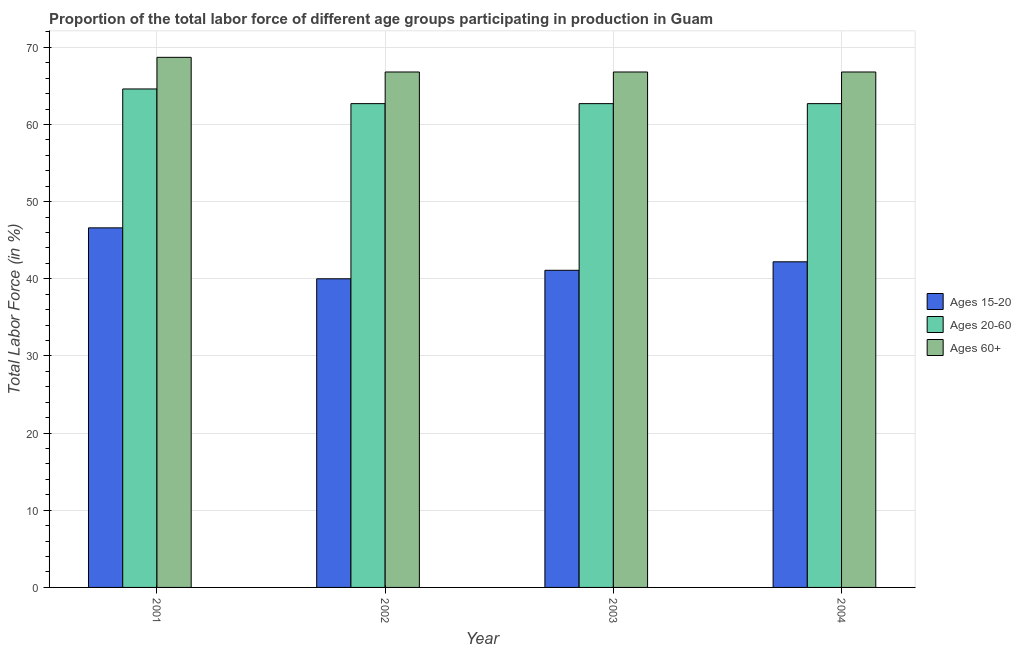How many groups of bars are there?
Your answer should be very brief. 4. Are the number of bars per tick equal to the number of legend labels?
Keep it short and to the point. Yes. Are the number of bars on each tick of the X-axis equal?
Give a very brief answer. Yes. How many bars are there on the 3rd tick from the left?
Your response must be concise. 3. What is the label of the 4th group of bars from the left?
Ensure brevity in your answer.  2004. What is the percentage of labor force above age 60 in 2003?
Offer a terse response. 66.8. Across all years, what is the maximum percentage of labor force within the age group 15-20?
Your answer should be very brief. 46.6. Across all years, what is the minimum percentage of labor force within the age group 15-20?
Offer a very short reply. 40. In which year was the percentage of labor force within the age group 20-60 minimum?
Offer a very short reply. 2002. What is the total percentage of labor force within the age group 15-20 in the graph?
Provide a succinct answer. 169.9. What is the difference between the percentage of labor force within the age group 15-20 in 2001 and that in 2004?
Provide a succinct answer. 4.4. What is the difference between the percentage of labor force above age 60 in 2003 and the percentage of labor force within the age group 20-60 in 2001?
Offer a terse response. -1.9. What is the average percentage of labor force within the age group 20-60 per year?
Ensure brevity in your answer.  63.18. In the year 2002, what is the difference between the percentage of labor force within the age group 15-20 and percentage of labor force above age 60?
Provide a short and direct response. 0. What is the ratio of the percentage of labor force within the age group 15-20 in 2002 to that in 2003?
Your response must be concise. 0.97. Is the percentage of labor force above age 60 in 2001 less than that in 2004?
Your response must be concise. No. What is the difference between the highest and the second highest percentage of labor force within the age group 15-20?
Give a very brief answer. 4.4. What is the difference between the highest and the lowest percentage of labor force within the age group 15-20?
Ensure brevity in your answer.  6.6. What does the 2nd bar from the left in 2003 represents?
Offer a very short reply. Ages 20-60. What does the 1st bar from the right in 2002 represents?
Provide a short and direct response. Ages 60+. Is it the case that in every year, the sum of the percentage of labor force within the age group 15-20 and percentage of labor force within the age group 20-60 is greater than the percentage of labor force above age 60?
Provide a short and direct response. Yes. How many bars are there?
Provide a succinct answer. 12. Are all the bars in the graph horizontal?
Make the answer very short. No. What is the difference between two consecutive major ticks on the Y-axis?
Ensure brevity in your answer.  10. Are the values on the major ticks of Y-axis written in scientific E-notation?
Provide a short and direct response. No. Where does the legend appear in the graph?
Keep it short and to the point. Center right. How are the legend labels stacked?
Offer a very short reply. Vertical. What is the title of the graph?
Your response must be concise. Proportion of the total labor force of different age groups participating in production in Guam. Does "Labor Market" appear as one of the legend labels in the graph?
Your answer should be very brief. No. What is the Total Labor Force (in %) in Ages 15-20 in 2001?
Ensure brevity in your answer.  46.6. What is the Total Labor Force (in %) in Ages 20-60 in 2001?
Your answer should be very brief. 64.6. What is the Total Labor Force (in %) in Ages 60+ in 2001?
Give a very brief answer. 68.7. What is the Total Labor Force (in %) in Ages 20-60 in 2002?
Your answer should be compact. 62.7. What is the Total Labor Force (in %) of Ages 60+ in 2002?
Give a very brief answer. 66.8. What is the Total Labor Force (in %) of Ages 15-20 in 2003?
Offer a terse response. 41.1. What is the Total Labor Force (in %) in Ages 20-60 in 2003?
Keep it short and to the point. 62.7. What is the Total Labor Force (in %) in Ages 60+ in 2003?
Give a very brief answer. 66.8. What is the Total Labor Force (in %) in Ages 15-20 in 2004?
Your answer should be compact. 42.2. What is the Total Labor Force (in %) of Ages 20-60 in 2004?
Your answer should be very brief. 62.7. What is the Total Labor Force (in %) in Ages 60+ in 2004?
Make the answer very short. 66.8. Across all years, what is the maximum Total Labor Force (in %) in Ages 15-20?
Provide a succinct answer. 46.6. Across all years, what is the maximum Total Labor Force (in %) of Ages 20-60?
Offer a very short reply. 64.6. Across all years, what is the maximum Total Labor Force (in %) in Ages 60+?
Provide a succinct answer. 68.7. Across all years, what is the minimum Total Labor Force (in %) in Ages 15-20?
Your answer should be very brief. 40. Across all years, what is the minimum Total Labor Force (in %) in Ages 20-60?
Your answer should be compact. 62.7. Across all years, what is the minimum Total Labor Force (in %) of Ages 60+?
Provide a succinct answer. 66.8. What is the total Total Labor Force (in %) of Ages 15-20 in the graph?
Ensure brevity in your answer.  169.9. What is the total Total Labor Force (in %) of Ages 20-60 in the graph?
Provide a short and direct response. 252.7. What is the total Total Labor Force (in %) in Ages 60+ in the graph?
Your response must be concise. 269.1. What is the difference between the Total Labor Force (in %) of Ages 20-60 in 2001 and that in 2003?
Give a very brief answer. 1.9. What is the difference between the Total Labor Force (in %) of Ages 60+ in 2001 and that in 2003?
Provide a succinct answer. 1.9. What is the difference between the Total Labor Force (in %) of Ages 60+ in 2002 and that in 2003?
Ensure brevity in your answer.  0. What is the difference between the Total Labor Force (in %) of Ages 15-20 in 2002 and that in 2004?
Provide a short and direct response. -2.2. What is the difference between the Total Labor Force (in %) of Ages 20-60 in 2002 and that in 2004?
Offer a very short reply. 0. What is the difference between the Total Labor Force (in %) of Ages 60+ in 2002 and that in 2004?
Give a very brief answer. 0. What is the difference between the Total Labor Force (in %) of Ages 15-20 in 2001 and the Total Labor Force (in %) of Ages 20-60 in 2002?
Your answer should be compact. -16.1. What is the difference between the Total Labor Force (in %) in Ages 15-20 in 2001 and the Total Labor Force (in %) in Ages 60+ in 2002?
Provide a short and direct response. -20.2. What is the difference between the Total Labor Force (in %) of Ages 15-20 in 2001 and the Total Labor Force (in %) of Ages 20-60 in 2003?
Your answer should be very brief. -16.1. What is the difference between the Total Labor Force (in %) of Ages 15-20 in 2001 and the Total Labor Force (in %) of Ages 60+ in 2003?
Offer a very short reply. -20.2. What is the difference between the Total Labor Force (in %) in Ages 15-20 in 2001 and the Total Labor Force (in %) in Ages 20-60 in 2004?
Offer a terse response. -16.1. What is the difference between the Total Labor Force (in %) of Ages 15-20 in 2001 and the Total Labor Force (in %) of Ages 60+ in 2004?
Offer a very short reply. -20.2. What is the difference between the Total Labor Force (in %) in Ages 20-60 in 2001 and the Total Labor Force (in %) in Ages 60+ in 2004?
Keep it short and to the point. -2.2. What is the difference between the Total Labor Force (in %) in Ages 15-20 in 2002 and the Total Labor Force (in %) in Ages 20-60 in 2003?
Keep it short and to the point. -22.7. What is the difference between the Total Labor Force (in %) of Ages 15-20 in 2002 and the Total Labor Force (in %) of Ages 60+ in 2003?
Your response must be concise. -26.8. What is the difference between the Total Labor Force (in %) in Ages 20-60 in 2002 and the Total Labor Force (in %) in Ages 60+ in 2003?
Offer a very short reply. -4.1. What is the difference between the Total Labor Force (in %) of Ages 15-20 in 2002 and the Total Labor Force (in %) of Ages 20-60 in 2004?
Your answer should be very brief. -22.7. What is the difference between the Total Labor Force (in %) in Ages 15-20 in 2002 and the Total Labor Force (in %) in Ages 60+ in 2004?
Give a very brief answer. -26.8. What is the difference between the Total Labor Force (in %) in Ages 20-60 in 2002 and the Total Labor Force (in %) in Ages 60+ in 2004?
Your response must be concise. -4.1. What is the difference between the Total Labor Force (in %) of Ages 15-20 in 2003 and the Total Labor Force (in %) of Ages 20-60 in 2004?
Make the answer very short. -21.6. What is the difference between the Total Labor Force (in %) of Ages 15-20 in 2003 and the Total Labor Force (in %) of Ages 60+ in 2004?
Offer a very short reply. -25.7. What is the difference between the Total Labor Force (in %) in Ages 20-60 in 2003 and the Total Labor Force (in %) in Ages 60+ in 2004?
Your answer should be very brief. -4.1. What is the average Total Labor Force (in %) of Ages 15-20 per year?
Provide a succinct answer. 42.48. What is the average Total Labor Force (in %) in Ages 20-60 per year?
Your answer should be compact. 63.17. What is the average Total Labor Force (in %) of Ages 60+ per year?
Offer a terse response. 67.28. In the year 2001, what is the difference between the Total Labor Force (in %) of Ages 15-20 and Total Labor Force (in %) of Ages 20-60?
Your answer should be compact. -18. In the year 2001, what is the difference between the Total Labor Force (in %) in Ages 15-20 and Total Labor Force (in %) in Ages 60+?
Offer a terse response. -22.1. In the year 2002, what is the difference between the Total Labor Force (in %) of Ages 15-20 and Total Labor Force (in %) of Ages 20-60?
Keep it short and to the point. -22.7. In the year 2002, what is the difference between the Total Labor Force (in %) of Ages 15-20 and Total Labor Force (in %) of Ages 60+?
Offer a very short reply. -26.8. In the year 2002, what is the difference between the Total Labor Force (in %) in Ages 20-60 and Total Labor Force (in %) in Ages 60+?
Ensure brevity in your answer.  -4.1. In the year 2003, what is the difference between the Total Labor Force (in %) in Ages 15-20 and Total Labor Force (in %) in Ages 20-60?
Keep it short and to the point. -21.6. In the year 2003, what is the difference between the Total Labor Force (in %) of Ages 15-20 and Total Labor Force (in %) of Ages 60+?
Offer a very short reply. -25.7. In the year 2003, what is the difference between the Total Labor Force (in %) of Ages 20-60 and Total Labor Force (in %) of Ages 60+?
Provide a succinct answer. -4.1. In the year 2004, what is the difference between the Total Labor Force (in %) in Ages 15-20 and Total Labor Force (in %) in Ages 20-60?
Make the answer very short. -20.5. In the year 2004, what is the difference between the Total Labor Force (in %) in Ages 15-20 and Total Labor Force (in %) in Ages 60+?
Make the answer very short. -24.6. What is the ratio of the Total Labor Force (in %) of Ages 15-20 in 2001 to that in 2002?
Make the answer very short. 1.17. What is the ratio of the Total Labor Force (in %) of Ages 20-60 in 2001 to that in 2002?
Keep it short and to the point. 1.03. What is the ratio of the Total Labor Force (in %) of Ages 60+ in 2001 to that in 2002?
Ensure brevity in your answer.  1.03. What is the ratio of the Total Labor Force (in %) in Ages 15-20 in 2001 to that in 2003?
Offer a very short reply. 1.13. What is the ratio of the Total Labor Force (in %) of Ages 20-60 in 2001 to that in 2003?
Your response must be concise. 1.03. What is the ratio of the Total Labor Force (in %) of Ages 60+ in 2001 to that in 2003?
Your answer should be compact. 1.03. What is the ratio of the Total Labor Force (in %) of Ages 15-20 in 2001 to that in 2004?
Offer a very short reply. 1.1. What is the ratio of the Total Labor Force (in %) of Ages 20-60 in 2001 to that in 2004?
Provide a succinct answer. 1.03. What is the ratio of the Total Labor Force (in %) in Ages 60+ in 2001 to that in 2004?
Offer a terse response. 1.03. What is the ratio of the Total Labor Force (in %) of Ages 15-20 in 2002 to that in 2003?
Your answer should be very brief. 0.97. What is the ratio of the Total Labor Force (in %) in Ages 20-60 in 2002 to that in 2003?
Provide a succinct answer. 1. What is the ratio of the Total Labor Force (in %) in Ages 15-20 in 2002 to that in 2004?
Make the answer very short. 0.95. What is the ratio of the Total Labor Force (in %) in Ages 20-60 in 2002 to that in 2004?
Your response must be concise. 1. What is the ratio of the Total Labor Force (in %) of Ages 15-20 in 2003 to that in 2004?
Your answer should be very brief. 0.97. What is the difference between the highest and the second highest Total Labor Force (in %) in Ages 15-20?
Ensure brevity in your answer.  4.4. What is the difference between the highest and the second highest Total Labor Force (in %) in Ages 20-60?
Keep it short and to the point. 1.9. 